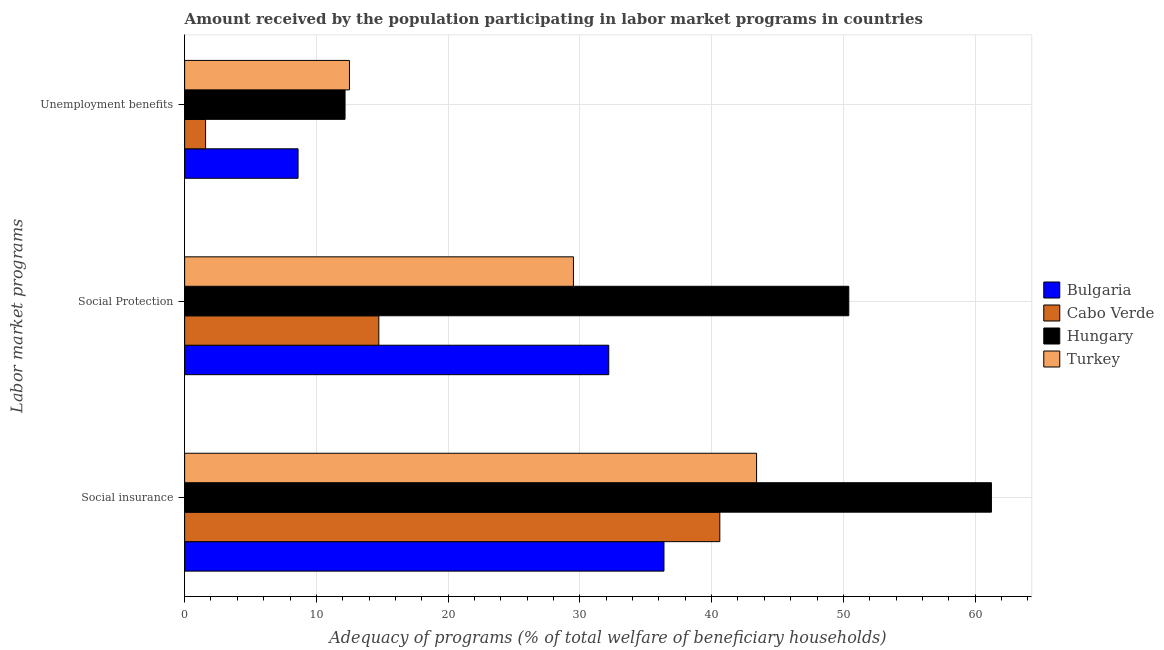How many different coloured bars are there?
Your answer should be very brief. 4. How many groups of bars are there?
Your answer should be very brief. 3. Are the number of bars on each tick of the Y-axis equal?
Offer a terse response. Yes. How many bars are there on the 1st tick from the top?
Offer a very short reply. 4. How many bars are there on the 2nd tick from the bottom?
Give a very brief answer. 4. What is the label of the 2nd group of bars from the top?
Provide a short and direct response. Social Protection. What is the amount received by the population participating in social protection programs in Turkey?
Give a very brief answer. 29.51. Across all countries, what is the maximum amount received by the population participating in unemployment benefits programs?
Give a very brief answer. 12.51. Across all countries, what is the minimum amount received by the population participating in social protection programs?
Give a very brief answer. 14.74. In which country was the amount received by the population participating in social insurance programs maximum?
Offer a very short reply. Hungary. In which country was the amount received by the population participating in social protection programs minimum?
Give a very brief answer. Cabo Verde. What is the total amount received by the population participating in unemployment benefits programs in the graph?
Ensure brevity in your answer.  34.88. What is the difference between the amount received by the population participating in social insurance programs in Hungary and that in Cabo Verde?
Give a very brief answer. 20.62. What is the difference between the amount received by the population participating in social insurance programs in Cabo Verde and the amount received by the population participating in unemployment benefits programs in Turkey?
Provide a succinct answer. 28.11. What is the average amount received by the population participating in social insurance programs per country?
Give a very brief answer. 45.41. What is the difference between the amount received by the population participating in social protection programs and amount received by the population participating in unemployment benefits programs in Turkey?
Provide a succinct answer. 17. In how many countries, is the amount received by the population participating in social insurance programs greater than 44 %?
Make the answer very short. 1. What is the ratio of the amount received by the population participating in social insurance programs in Cabo Verde to that in Bulgaria?
Ensure brevity in your answer.  1.12. Is the amount received by the population participating in social insurance programs in Turkey less than that in Bulgaria?
Give a very brief answer. No. What is the difference between the highest and the second highest amount received by the population participating in social insurance programs?
Make the answer very short. 17.82. What is the difference between the highest and the lowest amount received by the population participating in unemployment benefits programs?
Provide a short and direct response. 10.92. Is the sum of the amount received by the population participating in unemployment benefits programs in Hungary and Turkey greater than the maximum amount received by the population participating in social insurance programs across all countries?
Make the answer very short. No. What does the 4th bar from the top in Social Protection represents?
Your answer should be very brief. Bulgaria. What does the 4th bar from the bottom in Unemployment benefits represents?
Provide a succinct answer. Turkey. How many countries are there in the graph?
Make the answer very short. 4. What is the difference between two consecutive major ticks on the X-axis?
Offer a terse response. 10. Are the values on the major ticks of X-axis written in scientific E-notation?
Give a very brief answer. No. Does the graph contain any zero values?
Offer a very short reply. No. Does the graph contain grids?
Your answer should be very brief. Yes. How many legend labels are there?
Offer a terse response. 4. How are the legend labels stacked?
Ensure brevity in your answer.  Vertical. What is the title of the graph?
Provide a succinct answer. Amount received by the population participating in labor market programs in countries. What is the label or title of the X-axis?
Ensure brevity in your answer.  Adequacy of programs (% of total welfare of beneficiary households). What is the label or title of the Y-axis?
Provide a succinct answer. Labor market programs. What is the Adequacy of programs (% of total welfare of beneficiary households) in Bulgaria in Social insurance?
Make the answer very short. 36.38. What is the Adequacy of programs (% of total welfare of beneficiary households) in Cabo Verde in Social insurance?
Your answer should be very brief. 40.62. What is the Adequacy of programs (% of total welfare of beneficiary households) in Hungary in Social insurance?
Provide a succinct answer. 61.24. What is the Adequacy of programs (% of total welfare of beneficiary households) in Turkey in Social insurance?
Make the answer very short. 43.41. What is the Adequacy of programs (% of total welfare of beneficiary households) of Bulgaria in Social Protection?
Give a very brief answer. 32.19. What is the Adequacy of programs (% of total welfare of beneficiary households) of Cabo Verde in Social Protection?
Offer a terse response. 14.74. What is the Adequacy of programs (% of total welfare of beneficiary households) in Hungary in Social Protection?
Offer a very short reply. 50.41. What is the Adequacy of programs (% of total welfare of beneficiary households) of Turkey in Social Protection?
Give a very brief answer. 29.51. What is the Adequacy of programs (% of total welfare of beneficiary households) of Bulgaria in Unemployment benefits?
Give a very brief answer. 8.61. What is the Adequacy of programs (% of total welfare of beneficiary households) of Cabo Verde in Unemployment benefits?
Your response must be concise. 1.59. What is the Adequacy of programs (% of total welfare of beneficiary households) of Hungary in Unemployment benefits?
Your response must be concise. 12.17. What is the Adequacy of programs (% of total welfare of beneficiary households) in Turkey in Unemployment benefits?
Your answer should be compact. 12.51. Across all Labor market programs, what is the maximum Adequacy of programs (% of total welfare of beneficiary households) in Bulgaria?
Your answer should be very brief. 36.38. Across all Labor market programs, what is the maximum Adequacy of programs (% of total welfare of beneficiary households) in Cabo Verde?
Ensure brevity in your answer.  40.62. Across all Labor market programs, what is the maximum Adequacy of programs (% of total welfare of beneficiary households) in Hungary?
Ensure brevity in your answer.  61.24. Across all Labor market programs, what is the maximum Adequacy of programs (% of total welfare of beneficiary households) of Turkey?
Keep it short and to the point. 43.41. Across all Labor market programs, what is the minimum Adequacy of programs (% of total welfare of beneficiary households) of Bulgaria?
Keep it short and to the point. 8.61. Across all Labor market programs, what is the minimum Adequacy of programs (% of total welfare of beneficiary households) in Cabo Verde?
Ensure brevity in your answer.  1.59. Across all Labor market programs, what is the minimum Adequacy of programs (% of total welfare of beneficiary households) in Hungary?
Make the answer very short. 12.17. Across all Labor market programs, what is the minimum Adequacy of programs (% of total welfare of beneficiary households) of Turkey?
Offer a very short reply. 12.51. What is the total Adequacy of programs (% of total welfare of beneficiary households) of Bulgaria in the graph?
Your answer should be very brief. 77.18. What is the total Adequacy of programs (% of total welfare of beneficiary households) in Cabo Verde in the graph?
Offer a very short reply. 56.95. What is the total Adequacy of programs (% of total welfare of beneficiary households) in Hungary in the graph?
Your answer should be very brief. 123.82. What is the total Adequacy of programs (% of total welfare of beneficiary households) of Turkey in the graph?
Provide a succinct answer. 85.43. What is the difference between the Adequacy of programs (% of total welfare of beneficiary households) in Bulgaria in Social insurance and that in Social Protection?
Ensure brevity in your answer.  4.19. What is the difference between the Adequacy of programs (% of total welfare of beneficiary households) in Cabo Verde in Social insurance and that in Social Protection?
Your answer should be compact. 25.88. What is the difference between the Adequacy of programs (% of total welfare of beneficiary households) of Hungary in Social insurance and that in Social Protection?
Keep it short and to the point. 10.83. What is the difference between the Adequacy of programs (% of total welfare of beneficiary households) in Turkey in Social insurance and that in Social Protection?
Make the answer very short. 13.9. What is the difference between the Adequacy of programs (% of total welfare of beneficiary households) in Bulgaria in Social insurance and that in Unemployment benefits?
Provide a short and direct response. 27.77. What is the difference between the Adequacy of programs (% of total welfare of beneficiary households) in Cabo Verde in Social insurance and that in Unemployment benefits?
Offer a terse response. 39.03. What is the difference between the Adequacy of programs (% of total welfare of beneficiary households) of Hungary in Social insurance and that in Unemployment benefits?
Your response must be concise. 49.06. What is the difference between the Adequacy of programs (% of total welfare of beneficiary households) in Turkey in Social insurance and that in Unemployment benefits?
Offer a terse response. 30.9. What is the difference between the Adequacy of programs (% of total welfare of beneficiary households) of Bulgaria in Social Protection and that in Unemployment benefits?
Offer a very short reply. 23.58. What is the difference between the Adequacy of programs (% of total welfare of beneficiary households) of Cabo Verde in Social Protection and that in Unemployment benefits?
Your answer should be very brief. 13.15. What is the difference between the Adequacy of programs (% of total welfare of beneficiary households) in Hungary in Social Protection and that in Unemployment benefits?
Your answer should be very brief. 38.23. What is the difference between the Adequacy of programs (% of total welfare of beneficiary households) in Turkey in Social Protection and that in Unemployment benefits?
Give a very brief answer. 17. What is the difference between the Adequacy of programs (% of total welfare of beneficiary households) in Bulgaria in Social insurance and the Adequacy of programs (% of total welfare of beneficiary households) in Cabo Verde in Social Protection?
Your response must be concise. 21.64. What is the difference between the Adequacy of programs (% of total welfare of beneficiary households) in Bulgaria in Social insurance and the Adequacy of programs (% of total welfare of beneficiary households) in Hungary in Social Protection?
Your response must be concise. -14.03. What is the difference between the Adequacy of programs (% of total welfare of beneficiary households) in Bulgaria in Social insurance and the Adequacy of programs (% of total welfare of beneficiary households) in Turkey in Social Protection?
Your response must be concise. 6.87. What is the difference between the Adequacy of programs (% of total welfare of beneficiary households) of Cabo Verde in Social insurance and the Adequacy of programs (% of total welfare of beneficiary households) of Hungary in Social Protection?
Ensure brevity in your answer.  -9.79. What is the difference between the Adequacy of programs (% of total welfare of beneficiary households) of Cabo Verde in Social insurance and the Adequacy of programs (% of total welfare of beneficiary households) of Turkey in Social Protection?
Ensure brevity in your answer.  11.11. What is the difference between the Adequacy of programs (% of total welfare of beneficiary households) in Hungary in Social insurance and the Adequacy of programs (% of total welfare of beneficiary households) in Turkey in Social Protection?
Your answer should be very brief. 31.73. What is the difference between the Adequacy of programs (% of total welfare of beneficiary households) of Bulgaria in Social insurance and the Adequacy of programs (% of total welfare of beneficiary households) of Cabo Verde in Unemployment benefits?
Your answer should be very brief. 34.79. What is the difference between the Adequacy of programs (% of total welfare of beneficiary households) in Bulgaria in Social insurance and the Adequacy of programs (% of total welfare of beneficiary households) in Hungary in Unemployment benefits?
Ensure brevity in your answer.  24.21. What is the difference between the Adequacy of programs (% of total welfare of beneficiary households) of Bulgaria in Social insurance and the Adequacy of programs (% of total welfare of beneficiary households) of Turkey in Unemployment benefits?
Your answer should be very brief. 23.87. What is the difference between the Adequacy of programs (% of total welfare of beneficiary households) in Cabo Verde in Social insurance and the Adequacy of programs (% of total welfare of beneficiary households) in Hungary in Unemployment benefits?
Give a very brief answer. 28.45. What is the difference between the Adequacy of programs (% of total welfare of beneficiary households) of Cabo Verde in Social insurance and the Adequacy of programs (% of total welfare of beneficiary households) of Turkey in Unemployment benefits?
Offer a terse response. 28.11. What is the difference between the Adequacy of programs (% of total welfare of beneficiary households) in Hungary in Social insurance and the Adequacy of programs (% of total welfare of beneficiary households) in Turkey in Unemployment benefits?
Keep it short and to the point. 48.73. What is the difference between the Adequacy of programs (% of total welfare of beneficiary households) in Bulgaria in Social Protection and the Adequacy of programs (% of total welfare of beneficiary households) in Cabo Verde in Unemployment benefits?
Offer a very short reply. 30.6. What is the difference between the Adequacy of programs (% of total welfare of beneficiary households) of Bulgaria in Social Protection and the Adequacy of programs (% of total welfare of beneficiary households) of Hungary in Unemployment benefits?
Your answer should be compact. 20.02. What is the difference between the Adequacy of programs (% of total welfare of beneficiary households) in Bulgaria in Social Protection and the Adequacy of programs (% of total welfare of beneficiary households) in Turkey in Unemployment benefits?
Keep it short and to the point. 19.68. What is the difference between the Adequacy of programs (% of total welfare of beneficiary households) of Cabo Verde in Social Protection and the Adequacy of programs (% of total welfare of beneficiary households) of Hungary in Unemployment benefits?
Your response must be concise. 2.56. What is the difference between the Adequacy of programs (% of total welfare of beneficiary households) of Cabo Verde in Social Protection and the Adequacy of programs (% of total welfare of beneficiary households) of Turkey in Unemployment benefits?
Provide a succinct answer. 2.23. What is the difference between the Adequacy of programs (% of total welfare of beneficiary households) in Hungary in Social Protection and the Adequacy of programs (% of total welfare of beneficiary households) in Turkey in Unemployment benefits?
Give a very brief answer. 37.9. What is the average Adequacy of programs (% of total welfare of beneficiary households) in Bulgaria per Labor market programs?
Your answer should be compact. 25.73. What is the average Adequacy of programs (% of total welfare of beneficiary households) in Cabo Verde per Labor market programs?
Your answer should be compact. 18.98. What is the average Adequacy of programs (% of total welfare of beneficiary households) in Hungary per Labor market programs?
Make the answer very short. 41.27. What is the average Adequacy of programs (% of total welfare of beneficiary households) of Turkey per Labor market programs?
Give a very brief answer. 28.48. What is the difference between the Adequacy of programs (% of total welfare of beneficiary households) of Bulgaria and Adequacy of programs (% of total welfare of beneficiary households) of Cabo Verde in Social insurance?
Provide a succinct answer. -4.24. What is the difference between the Adequacy of programs (% of total welfare of beneficiary households) of Bulgaria and Adequacy of programs (% of total welfare of beneficiary households) of Hungary in Social insurance?
Offer a very short reply. -24.85. What is the difference between the Adequacy of programs (% of total welfare of beneficiary households) in Bulgaria and Adequacy of programs (% of total welfare of beneficiary households) in Turkey in Social insurance?
Provide a succinct answer. -7.03. What is the difference between the Adequacy of programs (% of total welfare of beneficiary households) of Cabo Verde and Adequacy of programs (% of total welfare of beneficiary households) of Hungary in Social insurance?
Your response must be concise. -20.62. What is the difference between the Adequacy of programs (% of total welfare of beneficiary households) of Cabo Verde and Adequacy of programs (% of total welfare of beneficiary households) of Turkey in Social insurance?
Your response must be concise. -2.79. What is the difference between the Adequacy of programs (% of total welfare of beneficiary households) of Hungary and Adequacy of programs (% of total welfare of beneficiary households) of Turkey in Social insurance?
Provide a succinct answer. 17.82. What is the difference between the Adequacy of programs (% of total welfare of beneficiary households) of Bulgaria and Adequacy of programs (% of total welfare of beneficiary households) of Cabo Verde in Social Protection?
Your response must be concise. 17.45. What is the difference between the Adequacy of programs (% of total welfare of beneficiary households) in Bulgaria and Adequacy of programs (% of total welfare of beneficiary households) in Hungary in Social Protection?
Provide a succinct answer. -18.22. What is the difference between the Adequacy of programs (% of total welfare of beneficiary households) in Bulgaria and Adequacy of programs (% of total welfare of beneficiary households) in Turkey in Social Protection?
Give a very brief answer. 2.68. What is the difference between the Adequacy of programs (% of total welfare of beneficiary households) in Cabo Verde and Adequacy of programs (% of total welfare of beneficiary households) in Hungary in Social Protection?
Make the answer very short. -35.67. What is the difference between the Adequacy of programs (% of total welfare of beneficiary households) in Cabo Verde and Adequacy of programs (% of total welfare of beneficiary households) in Turkey in Social Protection?
Give a very brief answer. -14.77. What is the difference between the Adequacy of programs (% of total welfare of beneficiary households) of Hungary and Adequacy of programs (% of total welfare of beneficiary households) of Turkey in Social Protection?
Provide a short and direct response. 20.9. What is the difference between the Adequacy of programs (% of total welfare of beneficiary households) in Bulgaria and Adequacy of programs (% of total welfare of beneficiary households) in Cabo Verde in Unemployment benefits?
Ensure brevity in your answer.  7.02. What is the difference between the Adequacy of programs (% of total welfare of beneficiary households) in Bulgaria and Adequacy of programs (% of total welfare of beneficiary households) in Hungary in Unemployment benefits?
Give a very brief answer. -3.57. What is the difference between the Adequacy of programs (% of total welfare of beneficiary households) in Bulgaria and Adequacy of programs (% of total welfare of beneficiary households) in Turkey in Unemployment benefits?
Your answer should be compact. -3.9. What is the difference between the Adequacy of programs (% of total welfare of beneficiary households) of Cabo Verde and Adequacy of programs (% of total welfare of beneficiary households) of Hungary in Unemployment benefits?
Give a very brief answer. -10.59. What is the difference between the Adequacy of programs (% of total welfare of beneficiary households) of Cabo Verde and Adequacy of programs (% of total welfare of beneficiary households) of Turkey in Unemployment benefits?
Keep it short and to the point. -10.92. What is the difference between the Adequacy of programs (% of total welfare of beneficiary households) in Hungary and Adequacy of programs (% of total welfare of beneficiary households) in Turkey in Unemployment benefits?
Offer a terse response. -0.34. What is the ratio of the Adequacy of programs (% of total welfare of beneficiary households) in Bulgaria in Social insurance to that in Social Protection?
Your answer should be compact. 1.13. What is the ratio of the Adequacy of programs (% of total welfare of beneficiary households) in Cabo Verde in Social insurance to that in Social Protection?
Provide a succinct answer. 2.76. What is the ratio of the Adequacy of programs (% of total welfare of beneficiary households) of Hungary in Social insurance to that in Social Protection?
Keep it short and to the point. 1.21. What is the ratio of the Adequacy of programs (% of total welfare of beneficiary households) of Turkey in Social insurance to that in Social Protection?
Provide a succinct answer. 1.47. What is the ratio of the Adequacy of programs (% of total welfare of beneficiary households) of Bulgaria in Social insurance to that in Unemployment benefits?
Offer a terse response. 4.23. What is the ratio of the Adequacy of programs (% of total welfare of beneficiary households) of Cabo Verde in Social insurance to that in Unemployment benefits?
Give a very brief answer. 25.56. What is the ratio of the Adequacy of programs (% of total welfare of beneficiary households) in Hungary in Social insurance to that in Unemployment benefits?
Offer a terse response. 5.03. What is the ratio of the Adequacy of programs (% of total welfare of beneficiary households) in Turkey in Social insurance to that in Unemployment benefits?
Your answer should be very brief. 3.47. What is the ratio of the Adequacy of programs (% of total welfare of beneficiary households) in Bulgaria in Social Protection to that in Unemployment benefits?
Provide a succinct answer. 3.74. What is the ratio of the Adequacy of programs (% of total welfare of beneficiary households) of Cabo Verde in Social Protection to that in Unemployment benefits?
Your answer should be compact. 9.27. What is the ratio of the Adequacy of programs (% of total welfare of beneficiary households) in Hungary in Social Protection to that in Unemployment benefits?
Offer a terse response. 4.14. What is the ratio of the Adequacy of programs (% of total welfare of beneficiary households) of Turkey in Social Protection to that in Unemployment benefits?
Your response must be concise. 2.36. What is the difference between the highest and the second highest Adequacy of programs (% of total welfare of beneficiary households) of Bulgaria?
Your response must be concise. 4.19. What is the difference between the highest and the second highest Adequacy of programs (% of total welfare of beneficiary households) in Cabo Verde?
Your answer should be very brief. 25.88. What is the difference between the highest and the second highest Adequacy of programs (% of total welfare of beneficiary households) of Hungary?
Give a very brief answer. 10.83. What is the difference between the highest and the second highest Adequacy of programs (% of total welfare of beneficiary households) in Turkey?
Give a very brief answer. 13.9. What is the difference between the highest and the lowest Adequacy of programs (% of total welfare of beneficiary households) in Bulgaria?
Make the answer very short. 27.77. What is the difference between the highest and the lowest Adequacy of programs (% of total welfare of beneficiary households) in Cabo Verde?
Make the answer very short. 39.03. What is the difference between the highest and the lowest Adequacy of programs (% of total welfare of beneficiary households) of Hungary?
Offer a very short reply. 49.06. What is the difference between the highest and the lowest Adequacy of programs (% of total welfare of beneficiary households) in Turkey?
Provide a short and direct response. 30.9. 